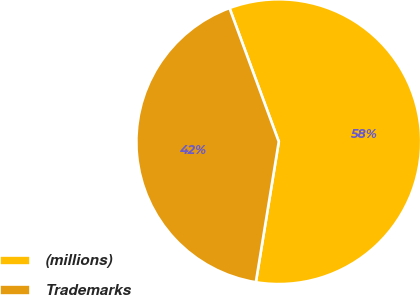Convert chart to OTSL. <chart><loc_0><loc_0><loc_500><loc_500><pie_chart><fcel>(millions)<fcel>Trademarks<nl><fcel>58.2%<fcel>41.8%<nl></chart> 